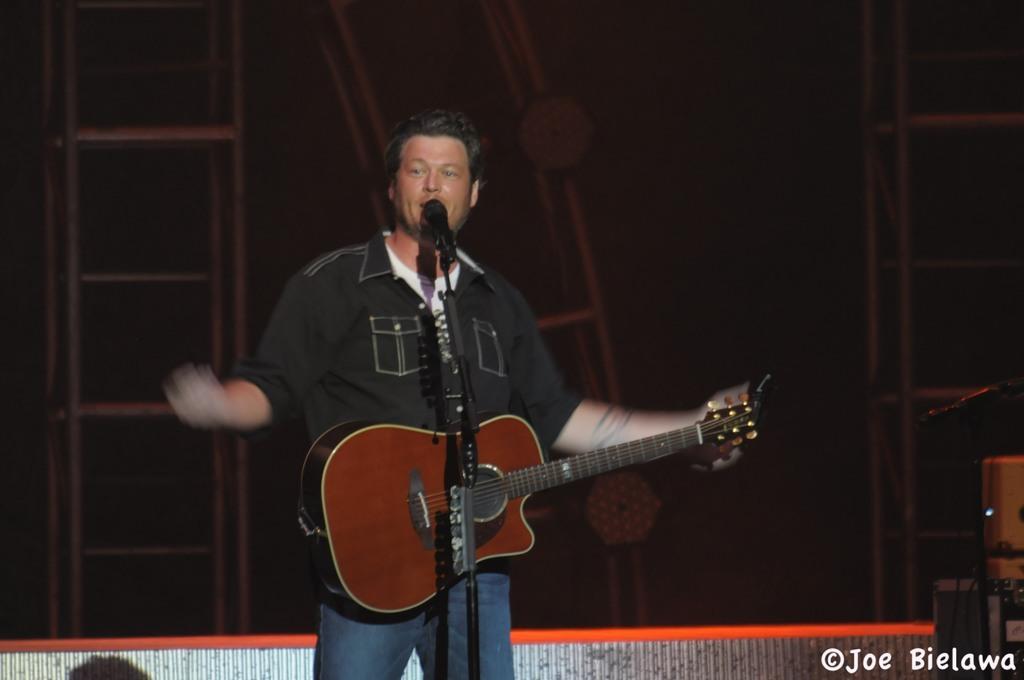Can you describe this image briefly? In this image I can see a man standing and holding a guitar. In front of this person there is a mike stand. It is looking like a stage. 